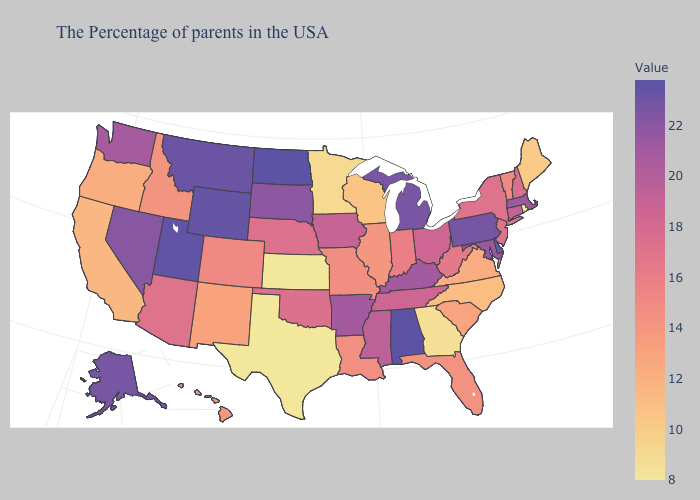Does Utah have a lower value than Connecticut?
Be succinct. No. Which states have the lowest value in the USA?
Write a very short answer. Kansas, Texas. 